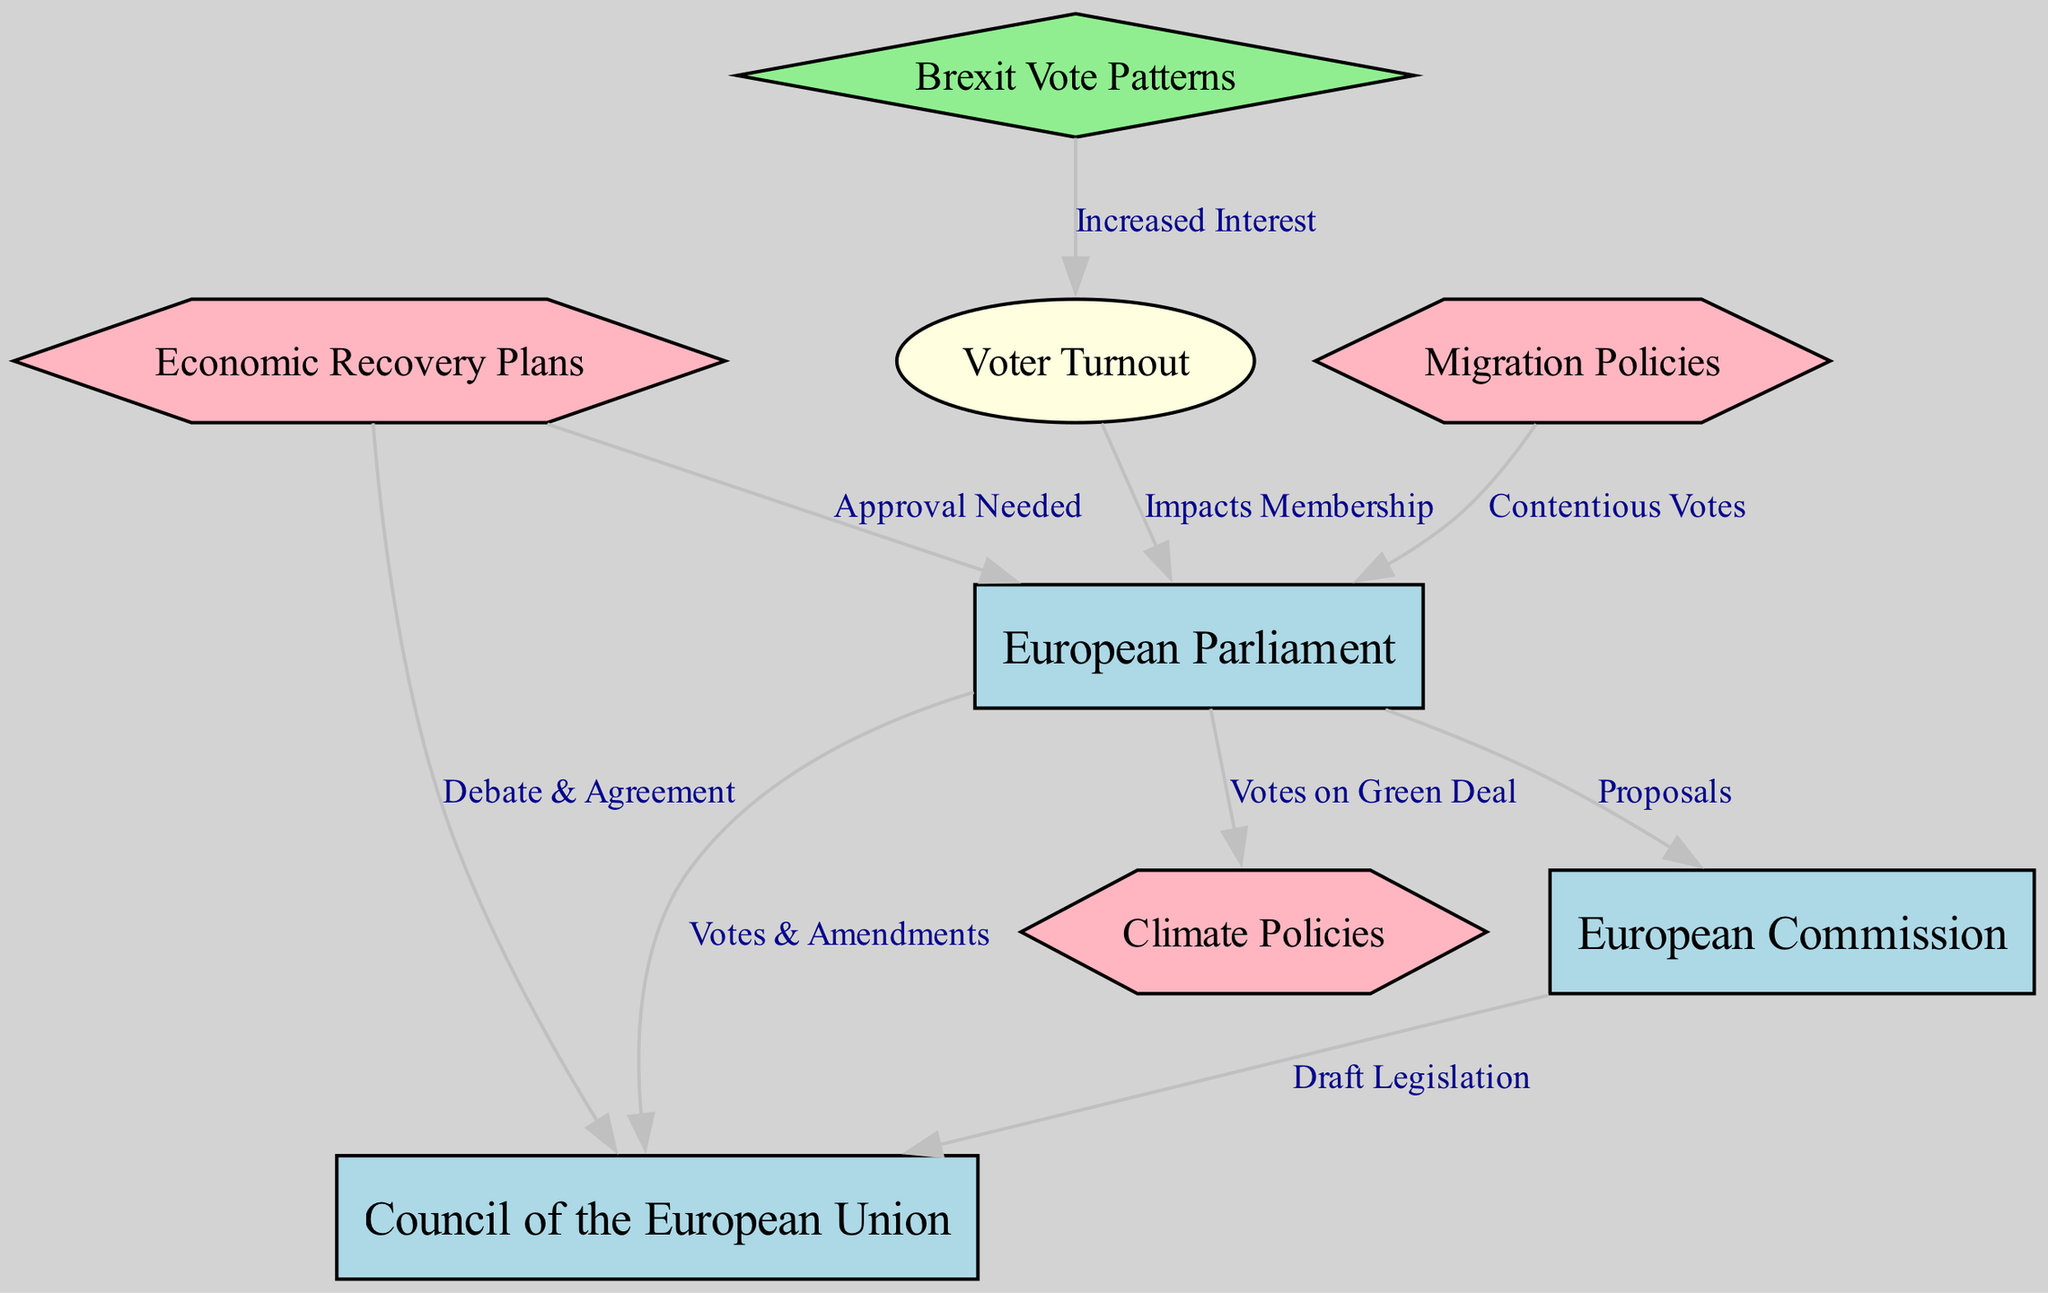What is the central institution shown in the diagram? The "European Parliament" is positioned at the center of the diagram, indicating its central role in the European Union's voting patterns.
Answer: European Parliament How many nodes are represented in the diagram? Counting all the nodes listed in the data, there are 8 nodes representing various aspects of the EU setup.
Answer: 8 Which policy is linked to the European Parliament via votes? The diagram indicates that "Climate Policies" is connected to the European Parliament specifically through the "Votes on Green Deal".
Answer: Climate Policies What type of relationship exists between the European Commission and the Council of the European Union? The diagram illustrates a "Draft Legislation" relationship, indicating how proposals move to legislation through these institutions.
Answer: Draft Legislation How does Brexit impact voter turnout? The diagram depicts that the Brexit issue has led to "Increased Interest" in voter turnout as illustrated by the link from Brexit to voter turnout.
Answer: Increased Interest Which policies require approval from the European Parliament? "Economic Recovery Plans" are specifically noted in the diagram as requiring approval from the European Parliament.
Answer: Economic Recovery Plans What is indicated by the "Impacts Membership" edge from Voter Turnout to the European Parliament? This edge signifies that voter turnout has a direct influence on the membership dynamics within the European Parliament.
Answer: Impacts Membership Which institution drafts legislation related to economic recovery plans? The diagram indicates a flow from "Economic Recovery Plans" to the "Council of the European Union," which suggests that the council debates and agrees on such legislation.
Answer: Council of the European Union How do contentious votes relate to migration policies? The diagram shows a direct connection between "Migration Policies" and "Contentious Votes," which signifies that migration is a hot topic within parliamentary discussions.
Answer: Contentious Votes 